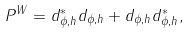Convert formula to latex. <formula><loc_0><loc_0><loc_500><loc_500>P ^ { W } = d _ { \phi , h } ^ { * } d _ { \phi , h } + d _ { \phi , h } d _ { \phi , h } ^ { * } ,</formula> 